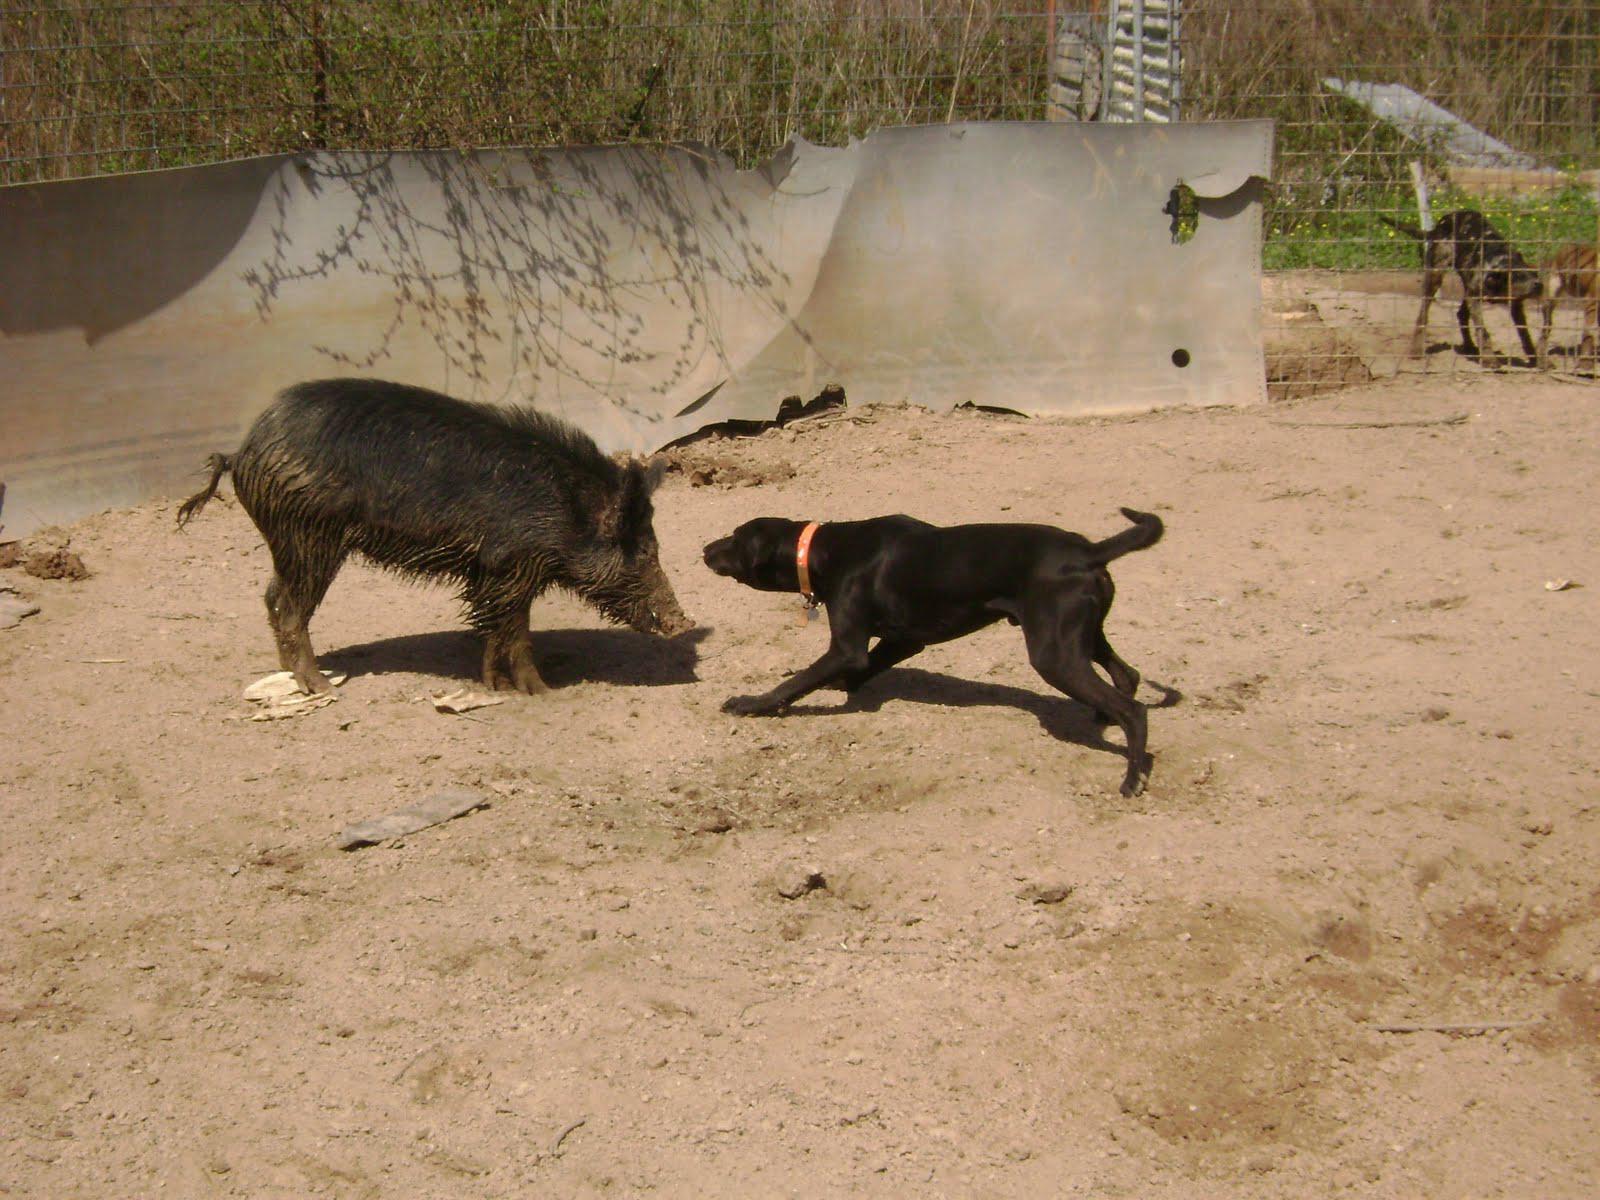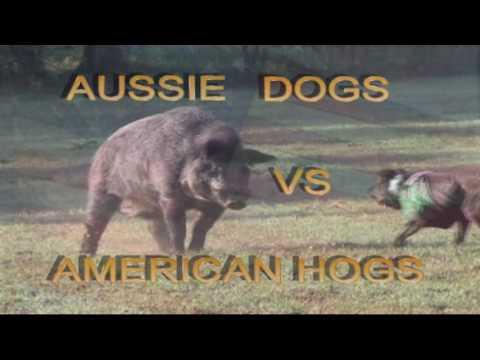The first image is the image on the left, the second image is the image on the right. Given the left and right images, does the statement "In at least one of the images, one dog is facing off with one hog." hold true? Answer yes or no. Yes. The first image is the image on the left, the second image is the image on the right. Considering the images on both sides, is "There are at least four black boars outside." valid? Answer yes or no. No. 